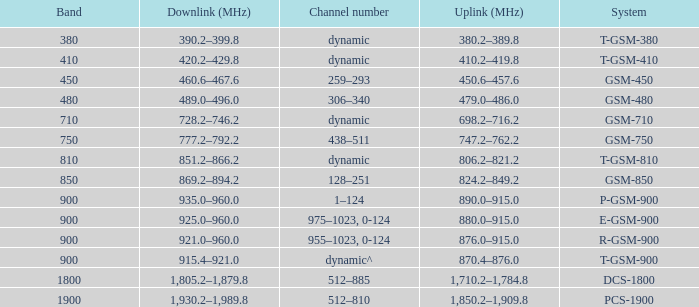What band is the highest and has a System of gsm-450? 450.0. 